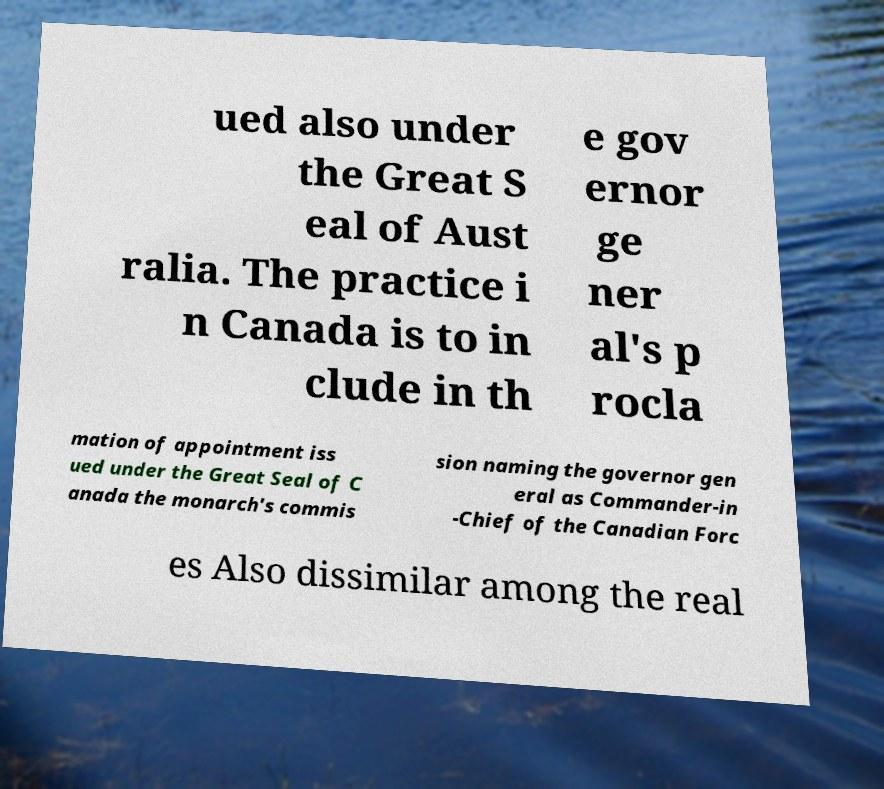I need the written content from this picture converted into text. Can you do that? ued also under the Great S eal of Aust ralia. The practice i n Canada is to in clude in th e gov ernor ge ner al's p rocla mation of appointment iss ued under the Great Seal of C anada the monarch's commis sion naming the governor gen eral as Commander-in -Chief of the Canadian Forc es Also dissimilar among the real 